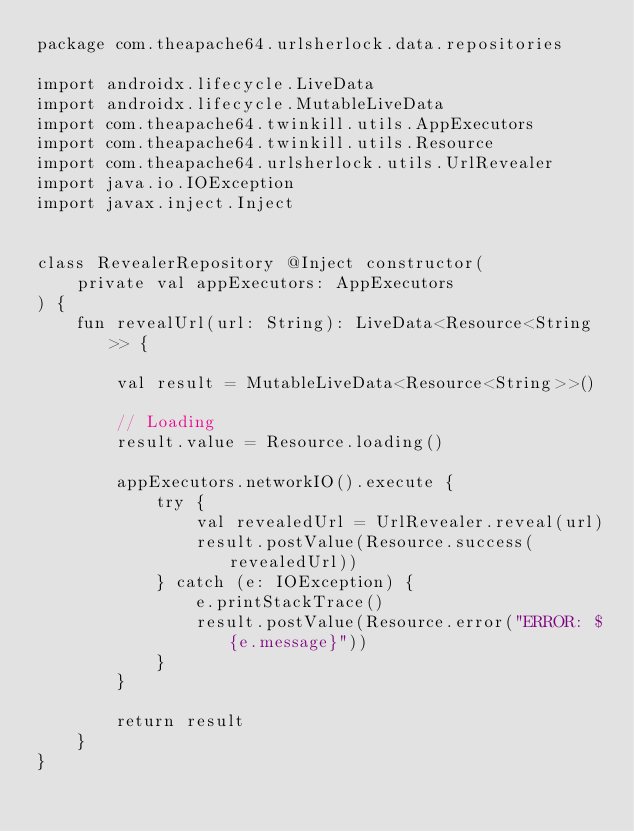Convert code to text. <code><loc_0><loc_0><loc_500><loc_500><_Kotlin_>package com.theapache64.urlsherlock.data.repositories

import androidx.lifecycle.LiveData
import androidx.lifecycle.MutableLiveData
import com.theapache64.twinkill.utils.AppExecutors
import com.theapache64.twinkill.utils.Resource
import com.theapache64.urlsherlock.utils.UrlRevealer
import java.io.IOException
import javax.inject.Inject


class RevealerRepository @Inject constructor(
    private val appExecutors: AppExecutors
) {
    fun revealUrl(url: String): LiveData<Resource<String>> {

        val result = MutableLiveData<Resource<String>>()

        // Loading
        result.value = Resource.loading()

        appExecutors.networkIO().execute {
            try {
                val revealedUrl = UrlRevealer.reveal(url)
                result.postValue(Resource.success(revealedUrl))
            } catch (e: IOException) {
                e.printStackTrace()
                result.postValue(Resource.error("ERROR: ${e.message}"))
            }
        }

        return result
    }
}</code> 